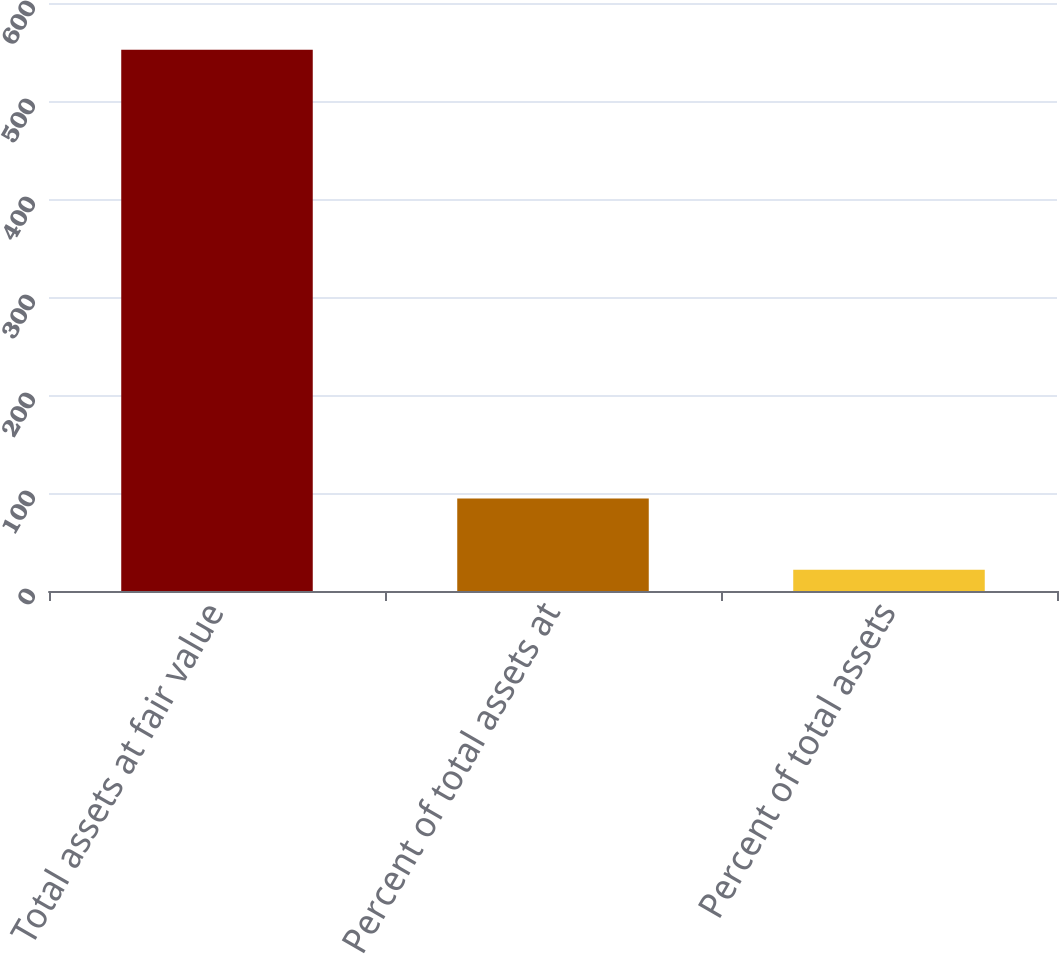Convert chart to OTSL. <chart><loc_0><loc_0><loc_500><loc_500><bar_chart><fcel>Total assets at fair value<fcel>Percent of total assets at<fcel>Percent of total assets<nl><fcel>552.4<fcel>94.4<fcel>21.6<nl></chart> 